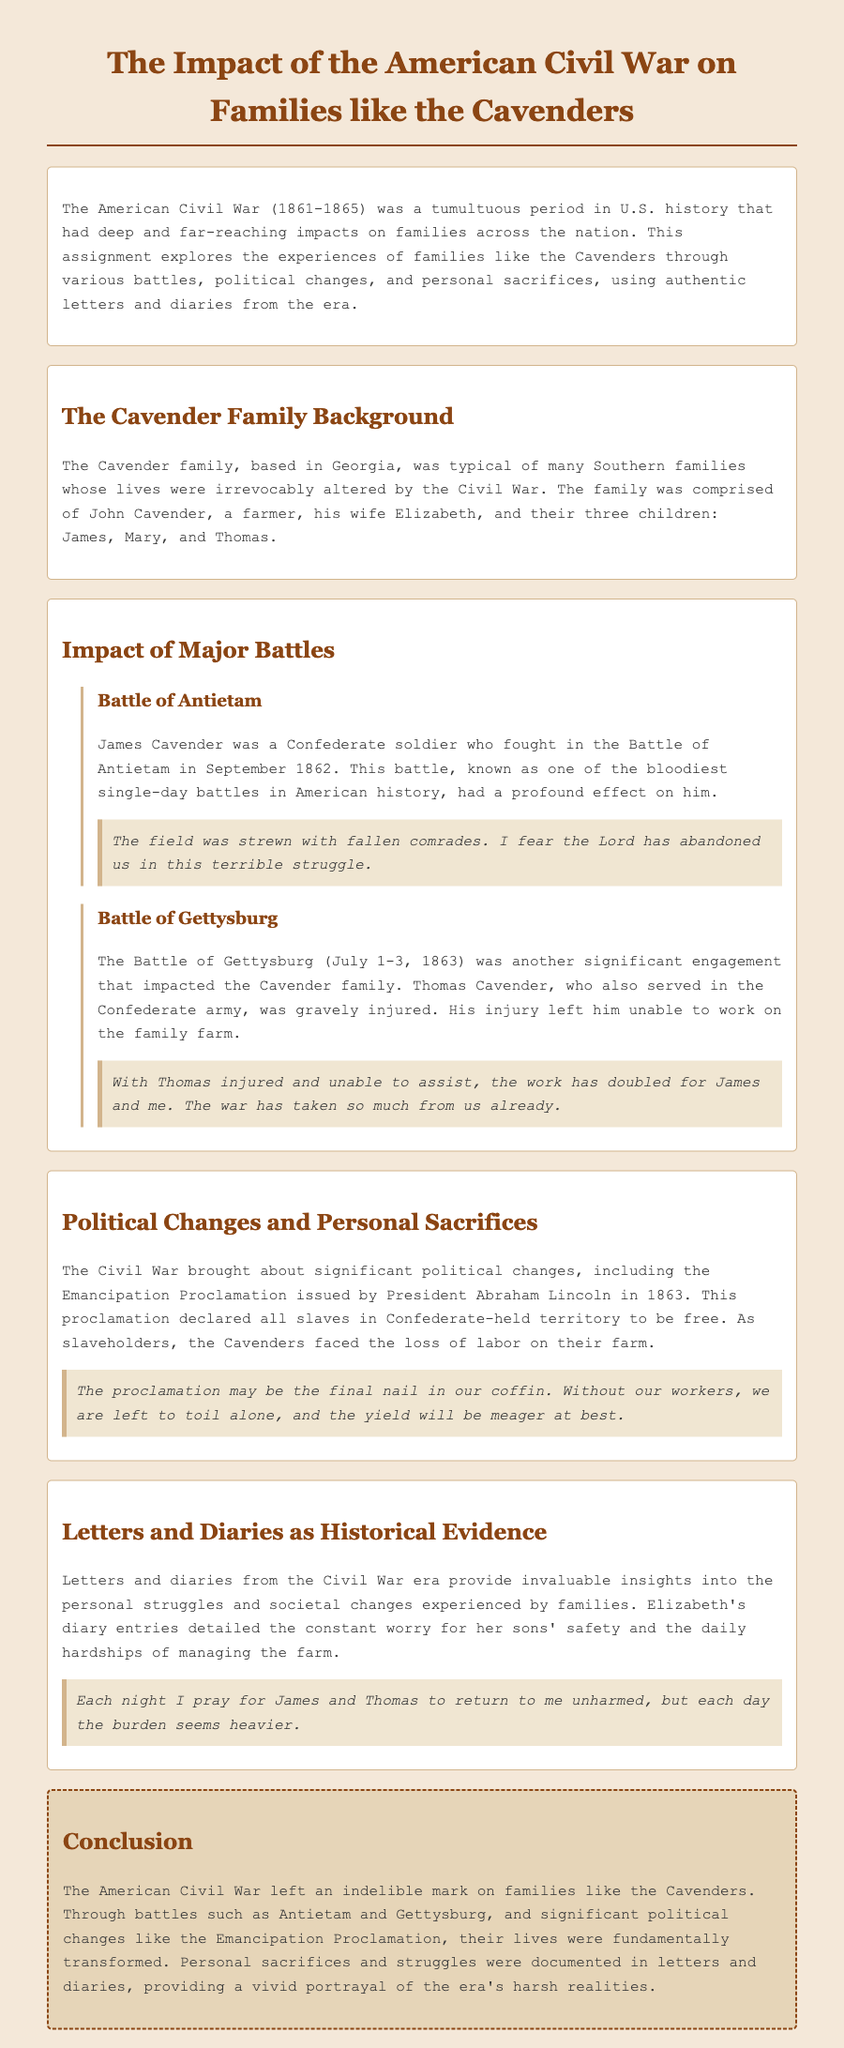What was the time frame of the American Civil War? The American Civil War lasted from 1861 to 1865.
Answer: 1861-1865 Who fought in the Battle of Antietam? James Cavender was a Confederate soldier who fought in this battle.
Answer: James Cavender Which significant battle left Thomas Cavender gravely injured? The Battle of Gettysburg resulted in Thomas's injury.
Answer: Gettysburg What political change did the Emancipation Proclamation introduce? The Emancipation Proclamation declared all slaves in Confederate-held territory to be free.
Answer: Freeing slaves How did Elizabeth Cavender feel about her sons' safety? Elizabeth expressed constant worry for her sons' safety in her diary entries.
Answer: Constant worry What impact did Thomas's injury have on the family farm? Thomas's injury left him unable to work, doubling the workload for James and Elizabeth.
Answer: Work doubled What is one major theme portrayed in the letters and diaries? The letters and diaries depict personal sacrifices and struggles during the Civil War.
Answer: Personal sacrifices In what state was the Cavender family based? The Cavender family was based in Georgia.
Answer: Georgia 